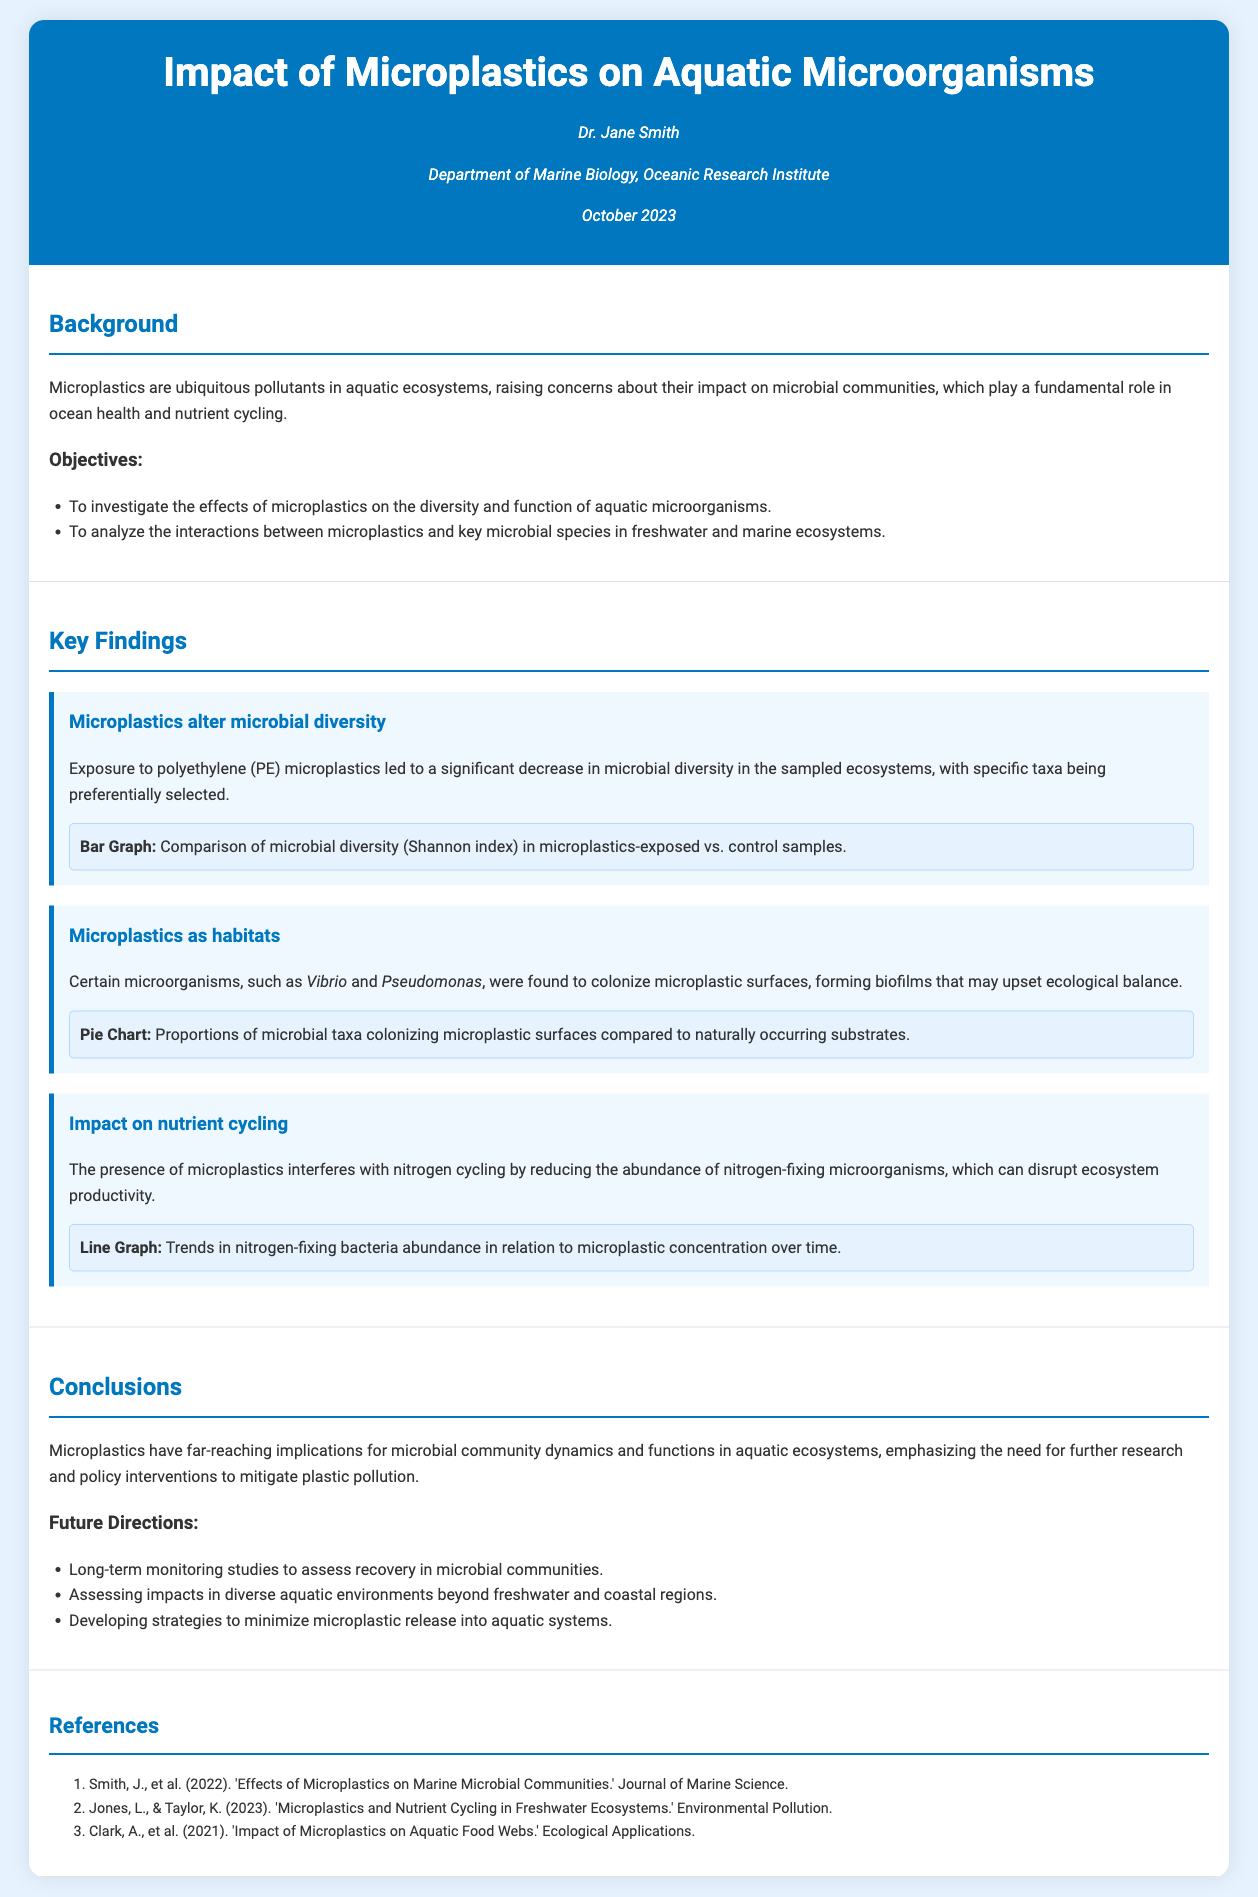What are the key objectives of the study? The key objectives are to investigate the effects of microplastics on microbial diversity and to analyze interactions between microplastics and key microbial species.
Answer: Effects on microbial diversity; interactions with microbial species What specific microorganisms were mentioned as colonizing microplastic surfaces? The document specifies that microorganisms such as Vibrio and Pseudomonas were found to colonize microplastic surfaces.
Answer: Vibrio and Pseudomonas What was the impact of polyethylene microplastics on microbial diversity? The document states that exposure to polyethylene microplastics led to a significant decrease in microbial diversity.
Answer: Significant decrease What type of chart was used to illustrate microbial taxa proportions? A pie chart was used to show the proportions of microbial taxa colonizing microplastic surfaces compared to naturally occurring substrates.
Answer: Pie chart What does the line graph in the findings represent? The line graph represents trends in nitrogen-fixing bacteria abundance in relation to microplastic concentration over time.
Answer: Trends in nitrogen-fixing bacteria abundance How many references are listed in the document? There are three references listed in the document.
Answer: Three What is one future direction mentioned for the study? One future direction mentioned is conducting long-term monitoring studies to assess recovery in microbial communities.
Answer: Long-term monitoring studies What does the background section highlight as a significant concern with microplastics? The background section highlights that microplastics raise concerns about their impact on microbial communities, which are vital for ocean health and nutrient cycling.
Answer: Impact on microbial communities When was the presentation given? The presentation was given in October 2023.
Answer: October 2023 